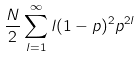<formula> <loc_0><loc_0><loc_500><loc_500>\frac { N } { 2 } \sum _ { l = 1 } ^ { \infty } l ( 1 - p ) ^ { 2 } p ^ { 2 l }</formula> 